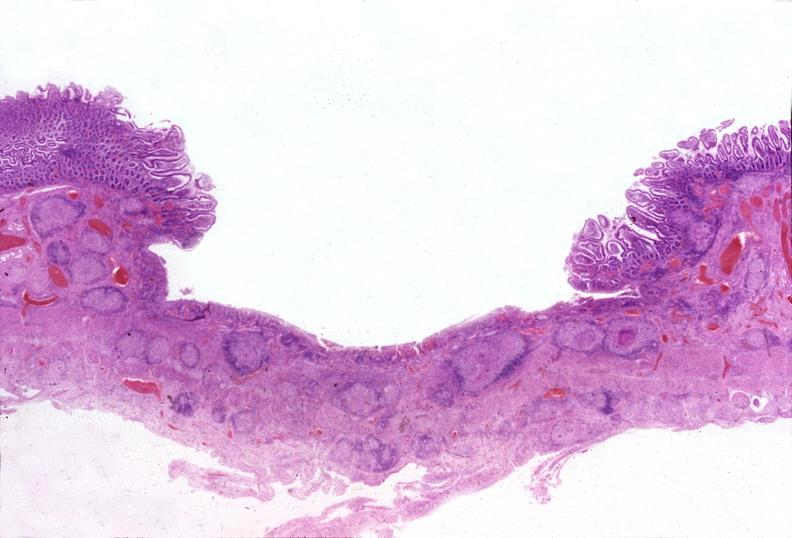what does this image show?
Answer the question using a single word or phrase. Small intestine 